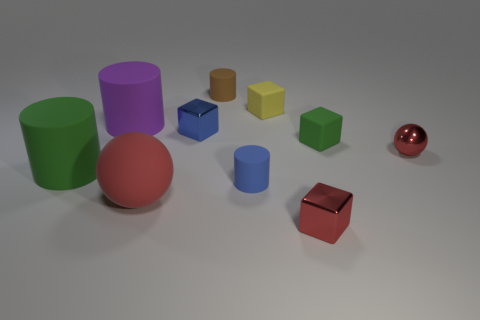Subtract 1 cubes. How many cubes are left? 3 Subtract all balls. How many objects are left? 8 Subtract all large red matte things. Subtract all purple objects. How many objects are left? 8 Add 4 small shiny balls. How many small shiny balls are left? 5 Add 1 red balls. How many red balls exist? 3 Subtract 0 blue balls. How many objects are left? 10 